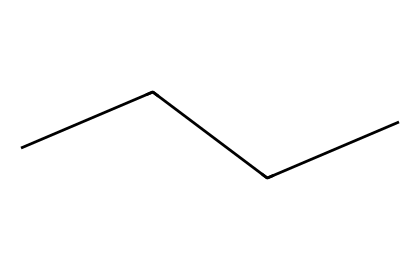What is the molecular formula of butane? By examining the structure represented by the SMILES notation "CCCC", it can be identified that the molecule consists of four carbon atoms (C) in a straight chain. Since it is a saturated hydrocarbon, it will also be associated with enough hydrogen atoms to satisfy each carbon's tetravalency. The molecular formula can therefore be deduced as C4H10.
Answer: C4H10 How many hydrogen atoms are present in butane? The structure "CCCC" indicates 4 carbon atoms (C). In a saturated hydrocarbon like butane, the number of hydrogen atoms is calculated using the formula H = 2n + 2, where n is the number of carbon atoms. Here n = 4, so H = 2(4) + 2 = 10. Therefore, butane has 10 hydrogen atoms.
Answer: 10 Is butane a liquid or gas at room temperature? Butane, while it can exist in both gaseous and liquid forms, is typically a gas at temperatures above its boiling point of around -0.5 degrees Celsius. At room temperature (about 20 degrees Celsius), it is in a gaseous state.
Answer: gas What type of hydrocarbon is butane classified as? Since butane is a straight-chain alkane composed entirely of carbon and hydrogen, it is classified specifically as a saturated hydrocarbon, which means it contains only single bonds between the carbon atoms.
Answer: saturated What is the boiling point of butane? The boiling point of butane is a known property, which is around -0.5 degrees Celsius. This property can be referenced from standard chemical data without needing to derive it from the structure.
Answer: -0.5 degrees Celsius How many carbon-carbon single bonds are in butane? Looking at the structure represented by "CCCC", it can be noted that there are three carbon-carbon single bonds connecting the four carbon atoms in a chain.
Answer: 3 Which type of isomerism can butane exhibit? Butane exhibits structural isomerism because it can exist in different forms that vary in the connectivity between atoms, such as n-butane and isobutane. This is a characteristic feature of aliphatic compounds with similar molecular formulas.
Answer: structural isomerism 